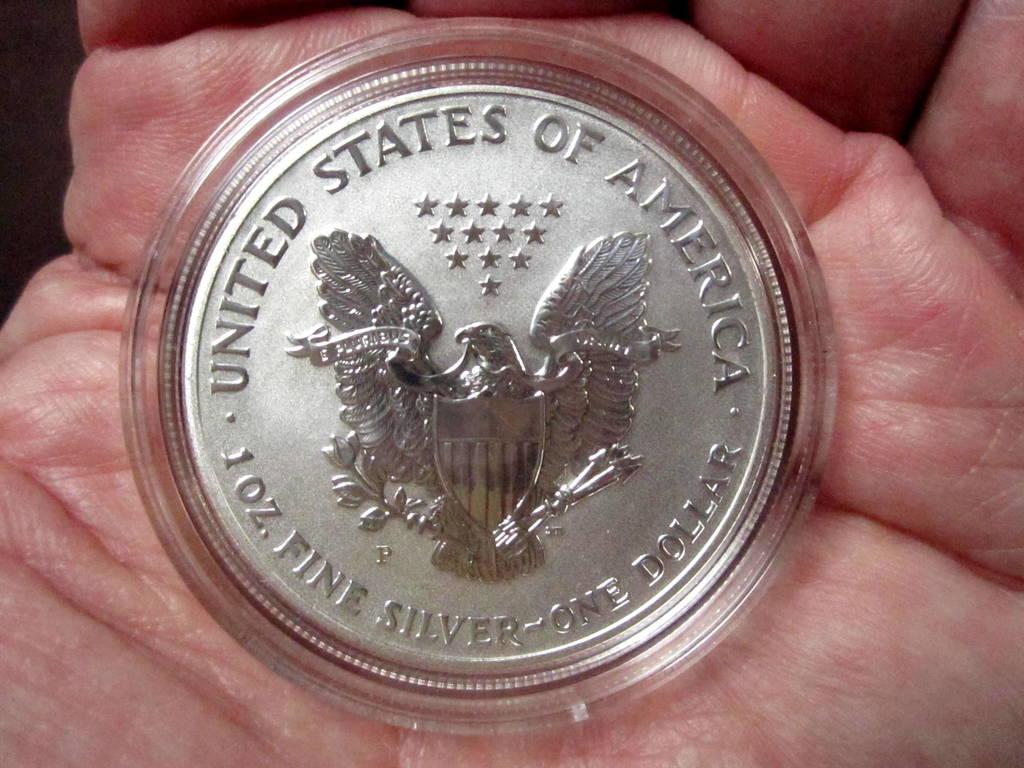<image>
Provide a brief description of the given image. The coin shown in a plastic cover is a silver one dollar coin. 